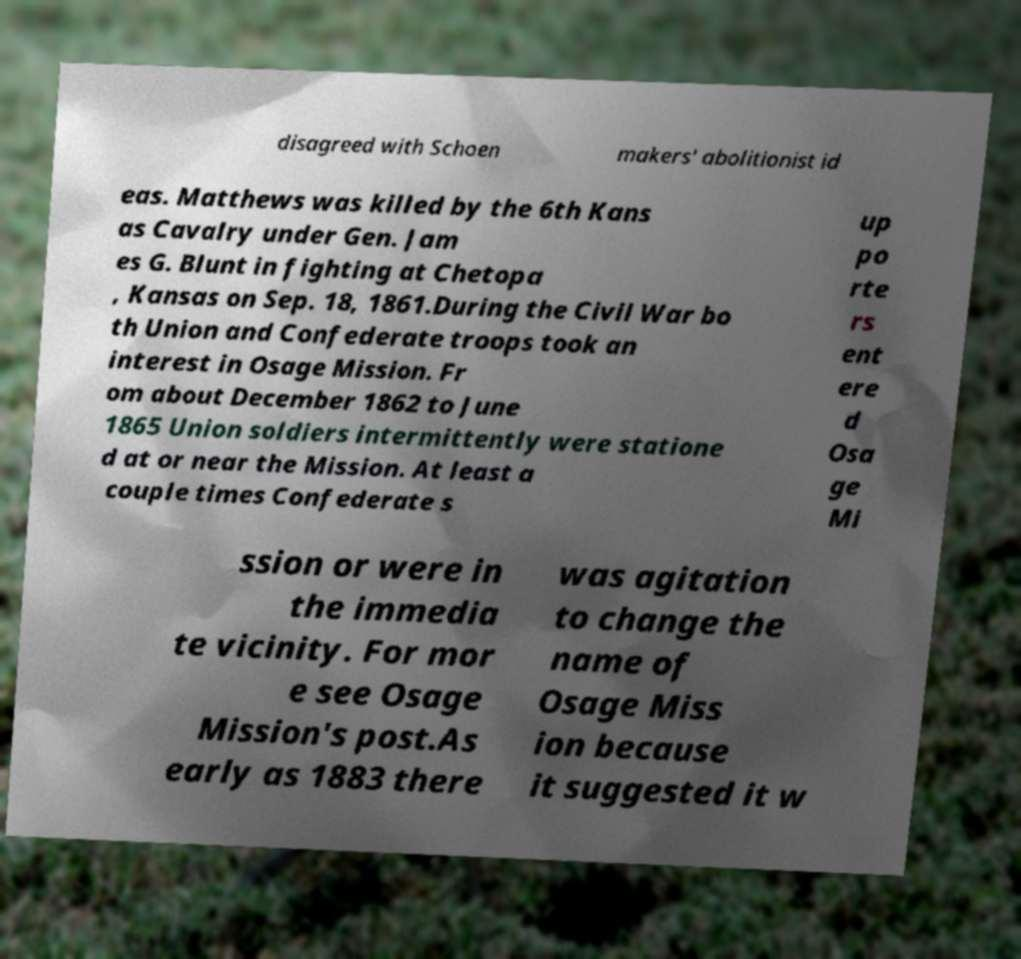For documentation purposes, I need the text within this image transcribed. Could you provide that? disagreed with Schoen makers' abolitionist id eas. Matthews was killed by the 6th Kans as Cavalry under Gen. Jam es G. Blunt in fighting at Chetopa , Kansas on Sep. 18, 1861.During the Civil War bo th Union and Confederate troops took an interest in Osage Mission. Fr om about December 1862 to June 1865 Union soldiers intermittently were statione d at or near the Mission. At least a couple times Confederate s up po rte rs ent ere d Osa ge Mi ssion or were in the immedia te vicinity. For mor e see Osage Mission's post.As early as 1883 there was agitation to change the name of Osage Miss ion because it suggested it w 